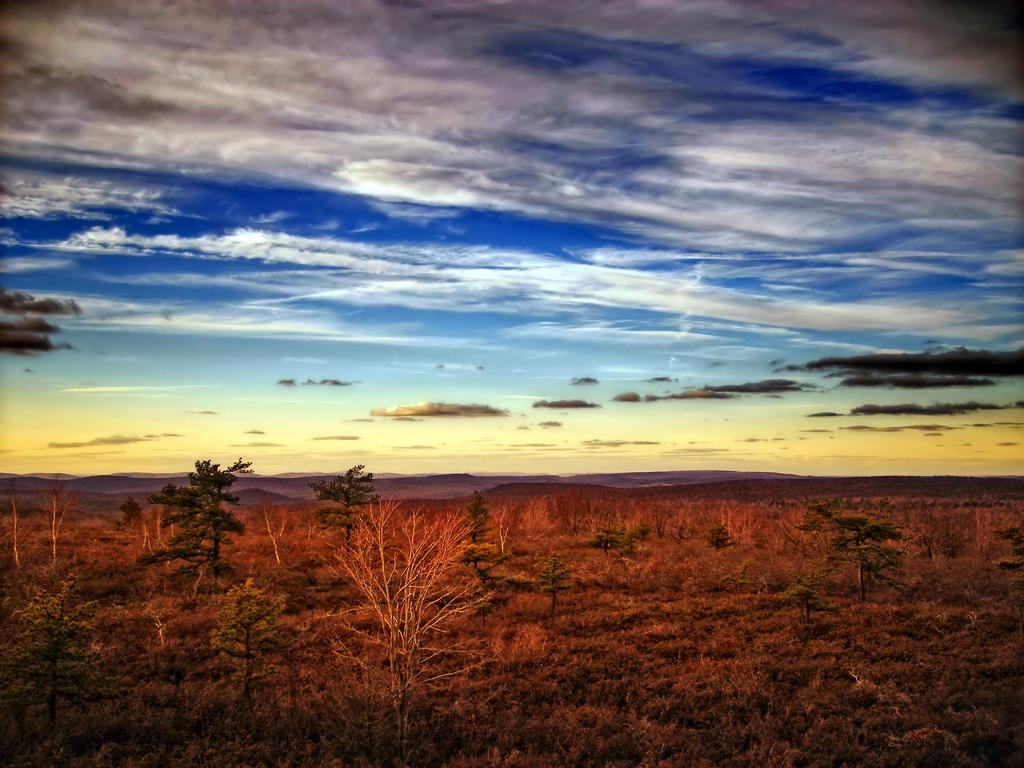What type of vegetation can be seen in the image? There is grass in the image. What other natural elements are present in the image? There are trees in the image. What can be seen in the background of the image? The sky is visible in the background of the image. What is the condition of the sky in the image? Clouds are present in the sky. How many kittens are sitting on the plate in the image? There is no plate or kittens present in the image. 